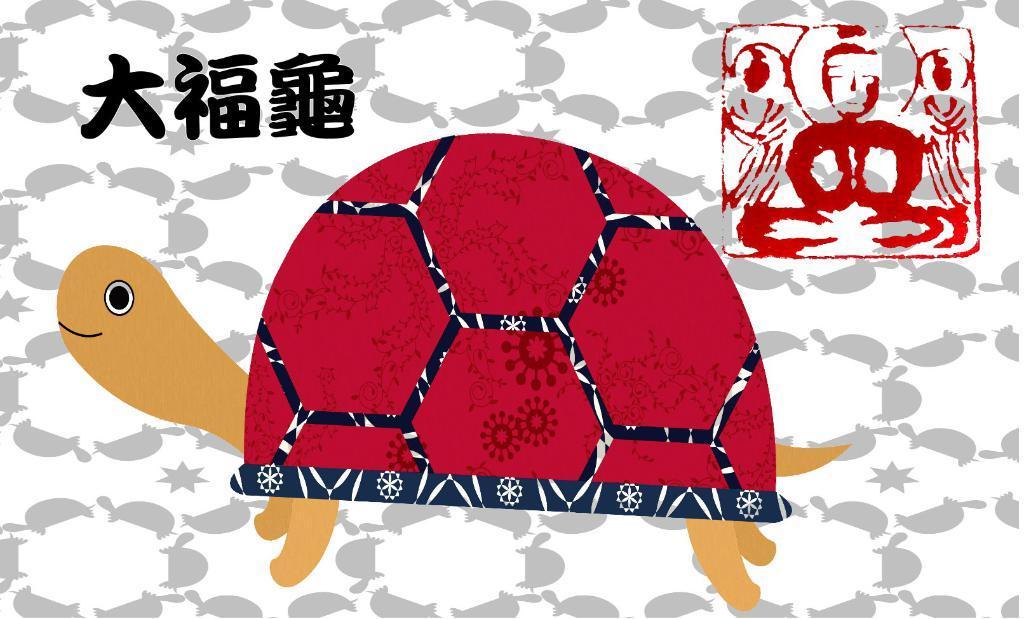Can you describe this image briefly? In this image we can see there is a painting. On the picture there is a tortoise and text. And at the back there is a background with a design. 